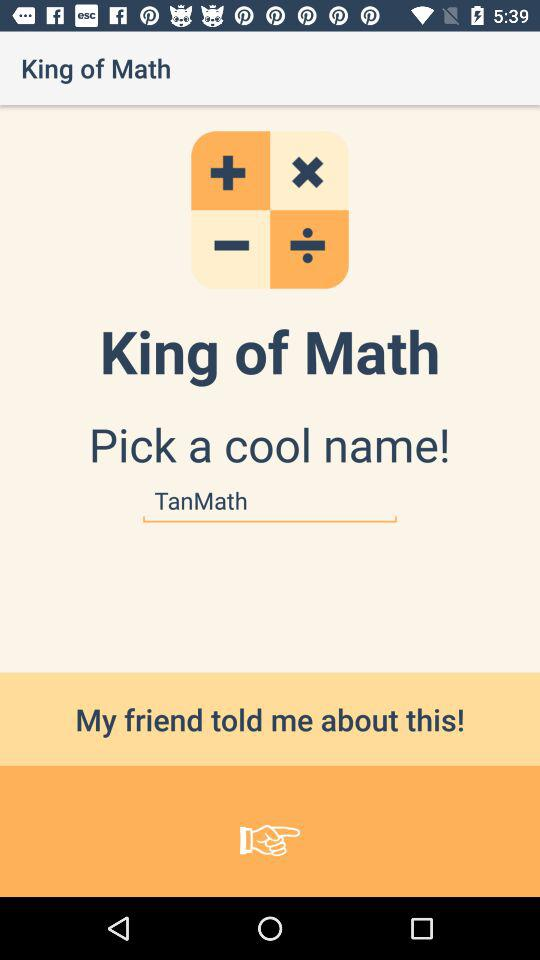What is the application name? The application name is "King of Math". 